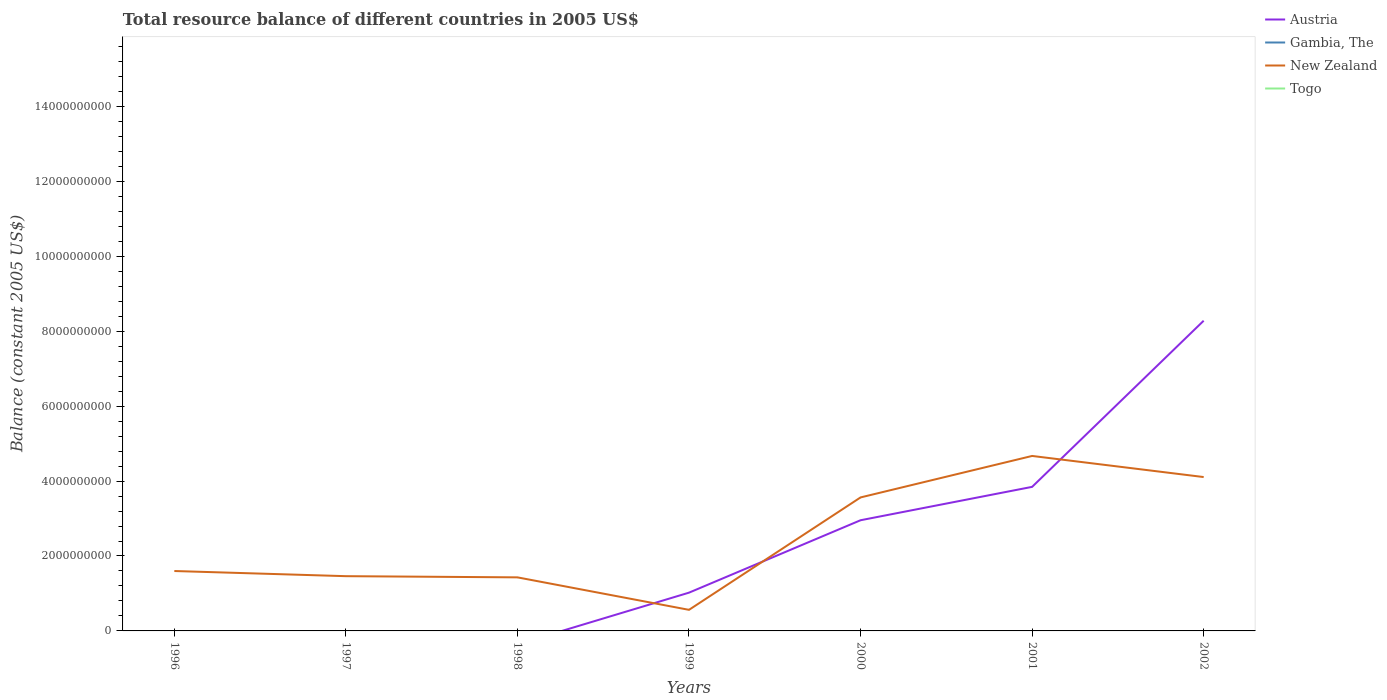How many different coloured lines are there?
Give a very brief answer. 2. Does the line corresponding to New Zealand intersect with the line corresponding to Gambia, The?
Your answer should be very brief. No. What is the total total resource balance in New Zealand in the graph?
Offer a terse response. -5.43e+08. What is the difference between the highest and the second highest total resource balance in Austria?
Give a very brief answer. 8.28e+09. What is the difference between the highest and the lowest total resource balance in Togo?
Your answer should be very brief. 0. What is the difference between two consecutive major ticks on the Y-axis?
Make the answer very short. 2.00e+09. Are the values on the major ticks of Y-axis written in scientific E-notation?
Your answer should be very brief. No. Does the graph contain grids?
Provide a succinct answer. No. What is the title of the graph?
Keep it short and to the point. Total resource balance of different countries in 2005 US$. What is the label or title of the Y-axis?
Make the answer very short. Balance (constant 2005 US$). What is the Balance (constant 2005 US$) of Gambia, The in 1996?
Ensure brevity in your answer.  0. What is the Balance (constant 2005 US$) in New Zealand in 1996?
Offer a very short reply. 1.60e+09. What is the Balance (constant 2005 US$) in Gambia, The in 1997?
Your answer should be compact. 0. What is the Balance (constant 2005 US$) in New Zealand in 1997?
Offer a terse response. 1.46e+09. What is the Balance (constant 2005 US$) in Togo in 1997?
Your answer should be compact. 0. What is the Balance (constant 2005 US$) in Austria in 1998?
Provide a short and direct response. 0. What is the Balance (constant 2005 US$) in Gambia, The in 1998?
Your response must be concise. 0. What is the Balance (constant 2005 US$) of New Zealand in 1998?
Your answer should be very brief. 1.43e+09. What is the Balance (constant 2005 US$) in Togo in 1998?
Offer a terse response. 0. What is the Balance (constant 2005 US$) in Austria in 1999?
Your answer should be compact. 1.02e+09. What is the Balance (constant 2005 US$) of New Zealand in 1999?
Offer a terse response. 5.63e+08. What is the Balance (constant 2005 US$) in Austria in 2000?
Give a very brief answer. 2.95e+09. What is the Balance (constant 2005 US$) of Gambia, The in 2000?
Give a very brief answer. 0. What is the Balance (constant 2005 US$) of New Zealand in 2000?
Ensure brevity in your answer.  3.56e+09. What is the Balance (constant 2005 US$) of Togo in 2000?
Your response must be concise. 0. What is the Balance (constant 2005 US$) of Austria in 2001?
Your response must be concise. 3.85e+09. What is the Balance (constant 2005 US$) in New Zealand in 2001?
Keep it short and to the point. 4.67e+09. What is the Balance (constant 2005 US$) in Togo in 2001?
Give a very brief answer. 0. What is the Balance (constant 2005 US$) in Austria in 2002?
Keep it short and to the point. 8.28e+09. What is the Balance (constant 2005 US$) of Gambia, The in 2002?
Ensure brevity in your answer.  0. What is the Balance (constant 2005 US$) in New Zealand in 2002?
Ensure brevity in your answer.  4.11e+09. Across all years, what is the maximum Balance (constant 2005 US$) of Austria?
Your answer should be compact. 8.28e+09. Across all years, what is the maximum Balance (constant 2005 US$) in New Zealand?
Give a very brief answer. 4.67e+09. Across all years, what is the minimum Balance (constant 2005 US$) in New Zealand?
Keep it short and to the point. 5.63e+08. What is the total Balance (constant 2005 US$) in Austria in the graph?
Give a very brief answer. 1.61e+1. What is the total Balance (constant 2005 US$) of New Zealand in the graph?
Ensure brevity in your answer.  1.74e+1. What is the total Balance (constant 2005 US$) in Togo in the graph?
Ensure brevity in your answer.  0. What is the difference between the Balance (constant 2005 US$) in New Zealand in 1996 and that in 1997?
Give a very brief answer. 1.38e+08. What is the difference between the Balance (constant 2005 US$) in New Zealand in 1996 and that in 1998?
Your answer should be very brief. 1.69e+08. What is the difference between the Balance (constant 2005 US$) of New Zealand in 1996 and that in 1999?
Offer a very short reply. 1.04e+09. What is the difference between the Balance (constant 2005 US$) in New Zealand in 1996 and that in 2000?
Your answer should be compact. -1.96e+09. What is the difference between the Balance (constant 2005 US$) of New Zealand in 1996 and that in 2001?
Keep it short and to the point. -3.07e+09. What is the difference between the Balance (constant 2005 US$) in New Zealand in 1996 and that in 2002?
Offer a very short reply. -2.51e+09. What is the difference between the Balance (constant 2005 US$) in New Zealand in 1997 and that in 1998?
Provide a short and direct response. 3.16e+07. What is the difference between the Balance (constant 2005 US$) of New Zealand in 1997 and that in 1999?
Ensure brevity in your answer.  8.98e+08. What is the difference between the Balance (constant 2005 US$) of New Zealand in 1997 and that in 2000?
Your response must be concise. -2.10e+09. What is the difference between the Balance (constant 2005 US$) in New Zealand in 1997 and that in 2001?
Ensure brevity in your answer.  -3.21e+09. What is the difference between the Balance (constant 2005 US$) of New Zealand in 1997 and that in 2002?
Provide a succinct answer. -2.65e+09. What is the difference between the Balance (constant 2005 US$) of New Zealand in 1998 and that in 1999?
Offer a very short reply. 8.67e+08. What is the difference between the Balance (constant 2005 US$) of New Zealand in 1998 and that in 2000?
Give a very brief answer. -2.13e+09. What is the difference between the Balance (constant 2005 US$) of New Zealand in 1998 and that in 2001?
Your response must be concise. -3.24e+09. What is the difference between the Balance (constant 2005 US$) in New Zealand in 1998 and that in 2002?
Give a very brief answer. -2.68e+09. What is the difference between the Balance (constant 2005 US$) in Austria in 1999 and that in 2000?
Your answer should be compact. -1.93e+09. What is the difference between the Balance (constant 2005 US$) of New Zealand in 1999 and that in 2000?
Offer a terse response. -3.00e+09. What is the difference between the Balance (constant 2005 US$) in Austria in 1999 and that in 2001?
Provide a short and direct response. -2.82e+09. What is the difference between the Balance (constant 2005 US$) in New Zealand in 1999 and that in 2001?
Give a very brief answer. -4.11e+09. What is the difference between the Balance (constant 2005 US$) of Austria in 1999 and that in 2002?
Your response must be concise. -7.26e+09. What is the difference between the Balance (constant 2005 US$) in New Zealand in 1999 and that in 2002?
Your answer should be very brief. -3.54e+09. What is the difference between the Balance (constant 2005 US$) of Austria in 2000 and that in 2001?
Your answer should be compact. -8.91e+08. What is the difference between the Balance (constant 2005 US$) of New Zealand in 2000 and that in 2001?
Ensure brevity in your answer.  -1.11e+09. What is the difference between the Balance (constant 2005 US$) of Austria in 2000 and that in 2002?
Give a very brief answer. -5.33e+09. What is the difference between the Balance (constant 2005 US$) in New Zealand in 2000 and that in 2002?
Your response must be concise. -5.43e+08. What is the difference between the Balance (constant 2005 US$) of Austria in 2001 and that in 2002?
Your answer should be very brief. -4.43e+09. What is the difference between the Balance (constant 2005 US$) in New Zealand in 2001 and that in 2002?
Provide a short and direct response. 5.63e+08. What is the difference between the Balance (constant 2005 US$) of Austria in 1999 and the Balance (constant 2005 US$) of New Zealand in 2000?
Provide a short and direct response. -2.54e+09. What is the difference between the Balance (constant 2005 US$) of Austria in 1999 and the Balance (constant 2005 US$) of New Zealand in 2001?
Your response must be concise. -3.65e+09. What is the difference between the Balance (constant 2005 US$) in Austria in 1999 and the Balance (constant 2005 US$) in New Zealand in 2002?
Your response must be concise. -3.09e+09. What is the difference between the Balance (constant 2005 US$) in Austria in 2000 and the Balance (constant 2005 US$) in New Zealand in 2001?
Offer a terse response. -1.72e+09. What is the difference between the Balance (constant 2005 US$) in Austria in 2000 and the Balance (constant 2005 US$) in New Zealand in 2002?
Provide a succinct answer. -1.15e+09. What is the difference between the Balance (constant 2005 US$) in Austria in 2001 and the Balance (constant 2005 US$) in New Zealand in 2002?
Your response must be concise. -2.61e+08. What is the average Balance (constant 2005 US$) of Austria per year?
Provide a succinct answer. 2.30e+09. What is the average Balance (constant 2005 US$) of New Zealand per year?
Give a very brief answer. 2.48e+09. In the year 1999, what is the difference between the Balance (constant 2005 US$) in Austria and Balance (constant 2005 US$) in New Zealand?
Your answer should be compact. 4.58e+08. In the year 2000, what is the difference between the Balance (constant 2005 US$) of Austria and Balance (constant 2005 US$) of New Zealand?
Your response must be concise. -6.09e+08. In the year 2001, what is the difference between the Balance (constant 2005 US$) in Austria and Balance (constant 2005 US$) in New Zealand?
Provide a short and direct response. -8.25e+08. In the year 2002, what is the difference between the Balance (constant 2005 US$) in Austria and Balance (constant 2005 US$) in New Zealand?
Offer a very short reply. 4.17e+09. What is the ratio of the Balance (constant 2005 US$) of New Zealand in 1996 to that in 1997?
Ensure brevity in your answer.  1.09. What is the ratio of the Balance (constant 2005 US$) in New Zealand in 1996 to that in 1998?
Offer a very short reply. 1.12. What is the ratio of the Balance (constant 2005 US$) in New Zealand in 1996 to that in 1999?
Your answer should be compact. 2.84. What is the ratio of the Balance (constant 2005 US$) in New Zealand in 1996 to that in 2000?
Provide a succinct answer. 0.45. What is the ratio of the Balance (constant 2005 US$) of New Zealand in 1996 to that in 2001?
Give a very brief answer. 0.34. What is the ratio of the Balance (constant 2005 US$) in New Zealand in 1996 to that in 2002?
Ensure brevity in your answer.  0.39. What is the ratio of the Balance (constant 2005 US$) in New Zealand in 1997 to that in 1998?
Keep it short and to the point. 1.02. What is the ratio of the Balance (constant 2005 US$) in New Zealand in 1997 to that in 1999?
Offer a terse response. 2.6. What is the ratio of the Balance (constant 2005 US$) in New Zealand in 1997 to that in 2000?
Your answer should be compact. 0.41. What is the ratio of the Balance (constant 2005 US$) in New Zealand in 1997 to that in 2001?
Provide a succinct answer. 0.31. What is the ratio of the Balance (constant 2005 US$) in New Zealand in 1997 to that in 2002?
Your answer should be very brief. 0.36. What is the ratio of the Balance (constant 2005 US$) of New Zealand in 1998 to that in 1999?
Your answer should be compact. 2.54. What is the ratio of the Balance (constant 2005 US$) in New Zealand in 1998 to that in 2000?
Make the answer very short. 0.4. What is the ratio of the Balance (constant 2005 US$) in New Zealand in 1998 to that in 2001?
Offer a terse response. 0.31. What is the ratio of the Balance (constant 2005 US$) of New Zealand in 1998 to that in 2002?
Provide a succinct answer. 0.35. What is the ratio of the Balance (constant 2005 US$) of Austria in 1999 to that in 2000?
Provide a succinct answer. 0.35. What is the ratio of the Balance (constant 2005 US$) of New Zealand in 1999 to that in 2000?
Provide a short and direct response. 0.16. What is the ratio of the Balance (constant 2005 US$) of Austria in 1999 to that in 2001?
Provide a short and direct response. 0.27. What is the ratio of the Balance (constant 2005 US$) in New Zealand in 1999 to that in 2001?
Your answer should be very brief. 0.12. What is the ratio of the Balance (constant 2005 US$) in Austria in 1999 to that in 2002?
Your answer should be very brief. 0.12. What is the ratio of the Balance (constant 2005 US$) of New Zealand in 1999 to that in 2002?
Provide a succinct answer. 0.14. What is the ratio of the Balance (constant 2005 US$) of Austria in 2000 to that in 2001?
Provide a succinct answer. 0.77. What is the ratio of the Balance (constant 2005 US$) of New Zealand in 2000 to that in 2001?
Provide a short and direct response. 0.76. What is the ratio of the Balance (constant 2005 US$) of Austria in 2000 to that in 2002?
Ensure brevity in your answer.  0.36. What is the ratio of the Balance (constant 2005 US$) of New Zealand in 2000 to that in 2002?
Your answer should be compact. 0.87. What is the ratio of the Balance (constant 2005 US$) of Austria in 2001 to that in 2002?
Your answer should be compact. 0.46. What is the ratio of the Balance (constant 2005 US$) of New Zealand in 2001 to that in 2002?
Offer a very short reply. 1.14. What is the difference between the highest and the second highest Balance (constant 2005 US$) of Austria?
Give a very brief answer. 4.43e+09. What is the difference between the highest and the second highest Balance (constant 2005 US$) in New Zealand?
Offer a very short reply. 5.63e+08. What is the difference between the highest and the lowest Balance (constant 2005 US$) of Austria?
Make the answer very short. 8.28e+09. What is the difference between the highest and the lowest Balance (constant 2005 US$) in New Zealand?
Make the answer very short. 4.11e+09. 